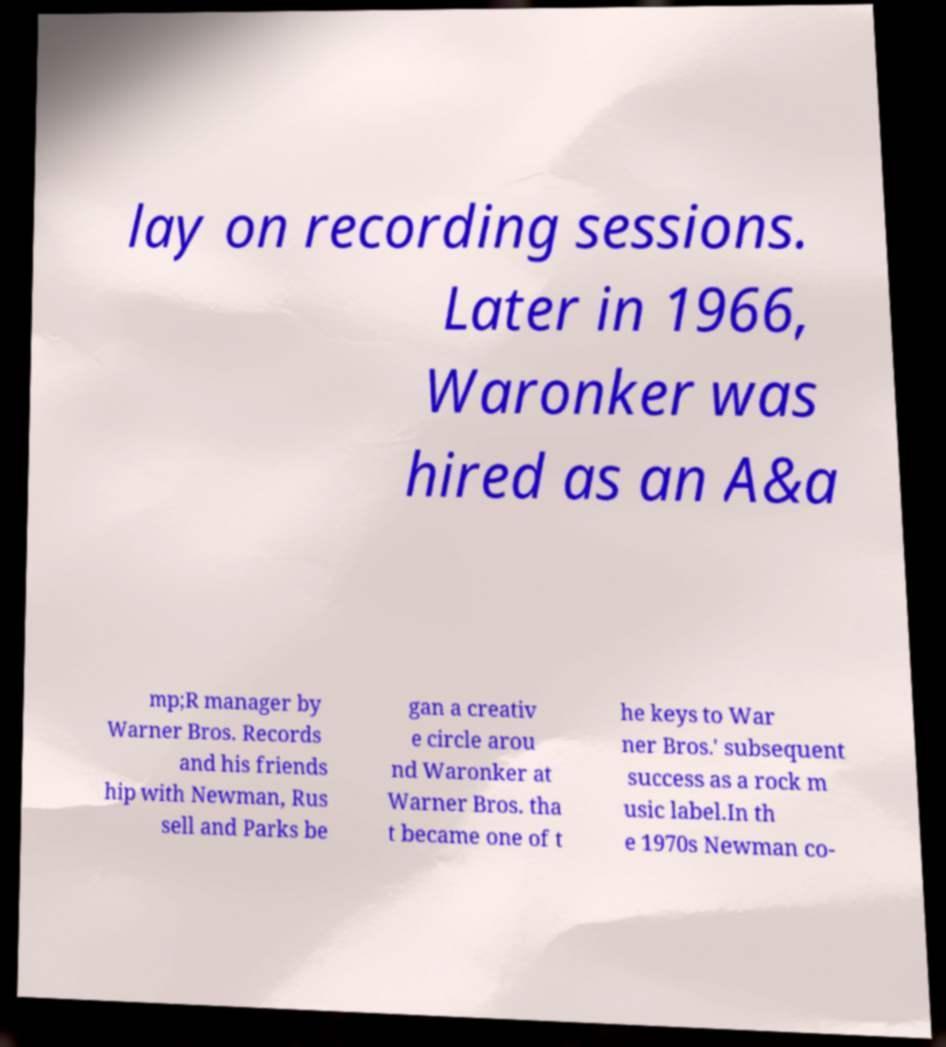Can you read and provide the text displayed in the image?This photo seems to have some interesting text. Can you extract and type it out for me? lay on recording sessions. Later in 1966, Waronker was hired as an A&a mp;R manager by Warner Bros. Records and his friends hip with Newman, Rus sell and Parks be gan a creativ e circle arou nd Waronker at Warner Bros. tha t became one of t he keys to War ner Bros.' subsequent success as a rock m usic label.In th e 1970s Newman co- 